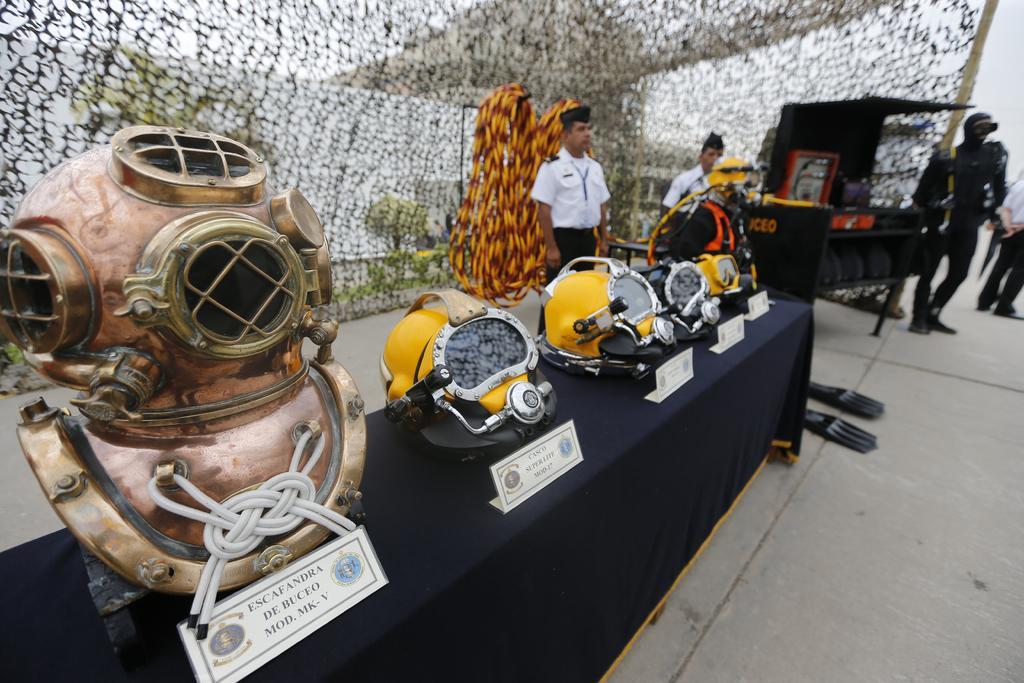Can you describe this image briefly? In this picture I can observe metal helmet on the left side. Beside the metal helmet I can observe yellow color helmets placed on the table. In the background I can observe some people standing on the floor. 